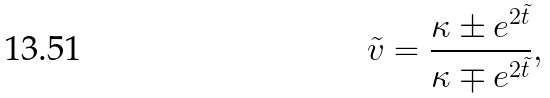Convert formula to latex. <formula><loc_0><loc_0><loc_500><loc_500>\tilde { v } = \frac { \kappa \pm e ^ { 2 \tilde { t } } } { \kappa \mp e ^ { 2 \tilde { t } } } ,</formula> 